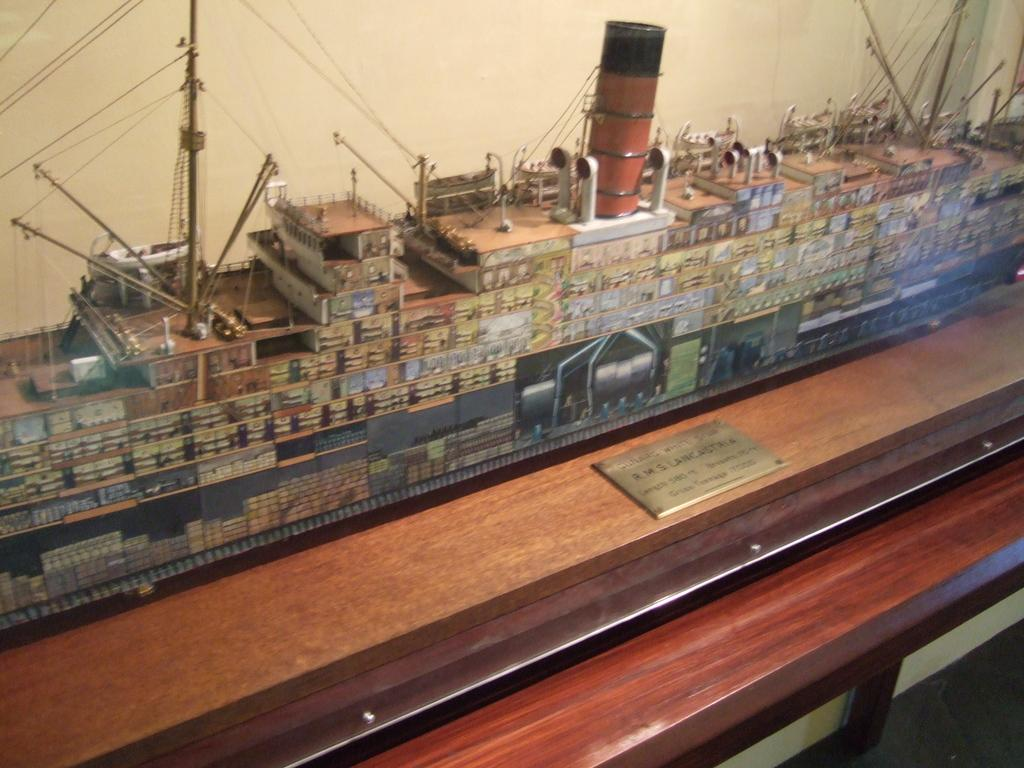What is the main subject of the image? The main subject of the image is a miniature ship. What else can be seen in the image besides the ship? There is a board in the image. Is there any text or information on the board? Yes, something is written on the board. How many pies are being served on the trip in the image? There is no trip or pies present in the image; it features a miniature ship and a board with writing. 